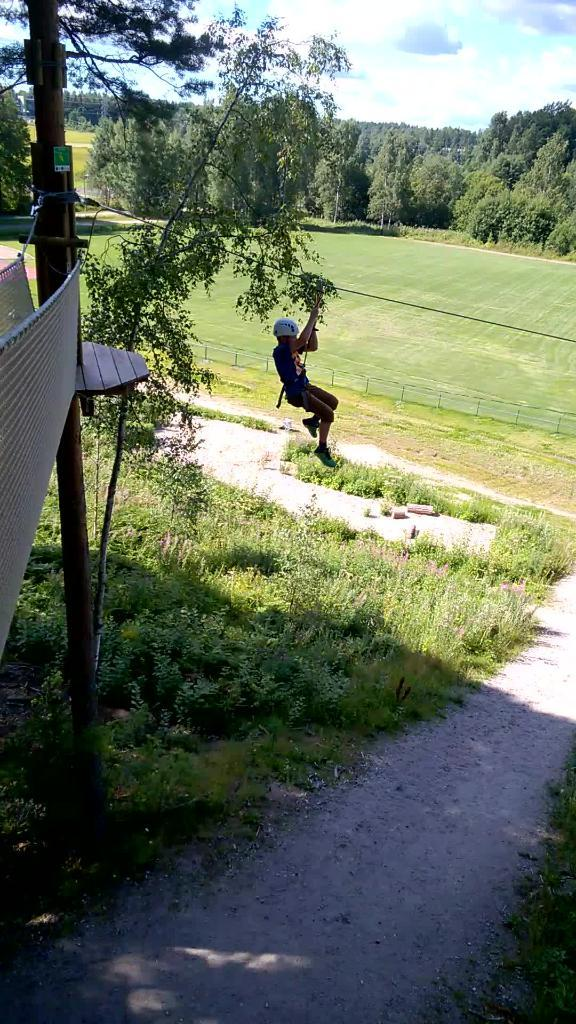What type of vegetation can be seen in the image? There is grass and plants on the ground in the image. Can you describe the person in the image? There is a person in the image, but their specific appearance or actions are not mentioned in the facts. What structures are present in the image? There is a pole and a fence in the image. What else can be seen on the ground in the image? There are some objects on the ground in the image. What is visible in the background of the image? There are trees and sky visible in the background of the image. How many houses are visible in the image? There are no houses mentioned or visible in the image. What type of rose can be seen in the image? There is no rose present in the image. 